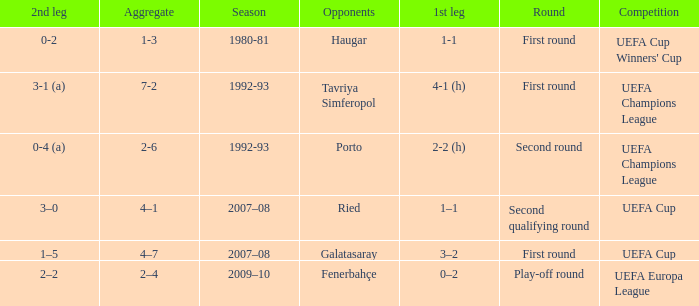 what's the aggregate where 1st leg is 3–2 4–7. 